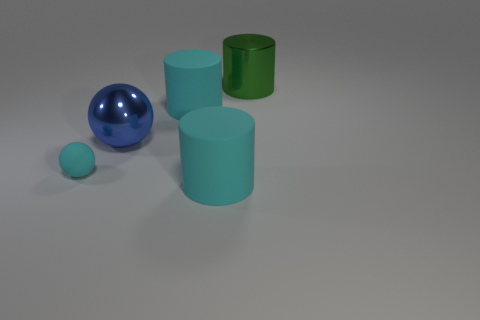There is a big thing that is the same material as the blue sphere; what color is it?
Your answer should be very brief. Green. There is a metallic thing in front of the green thing; is its size the same as the big green cylinder?
Offer a terse response. Yes. What number of things are large matte objects or big green metal objects?
Give a very brief answer. 3. There is a big cyan cylinder that is to the right of the big cyan rubber cylinder that is behind the shiny object left of the large green metal object; what is it made of?
Make the answer very short. Rubber. There is a cyan object that is on the left side of the big blue shiny sphere; what is its material?
Your answer should be compact. Rubber. Are there any cylinders of the same size as the blue object?
Offer a very short reply. Yes. Is the color of the big matte cylinder that is behind the big blue sphere the same as the small matte object?
Ensure brevity in your answer.  Yes. What number of yellow things are either tiny objects or large metal cylinders?
Offer a very short reply. 0. What number of cylinders are the same color as the small rubber ball?
Offer a very short reply. 2. Do the green object and the small cyan ball have the same material?
Keep it short and to the point. No. 